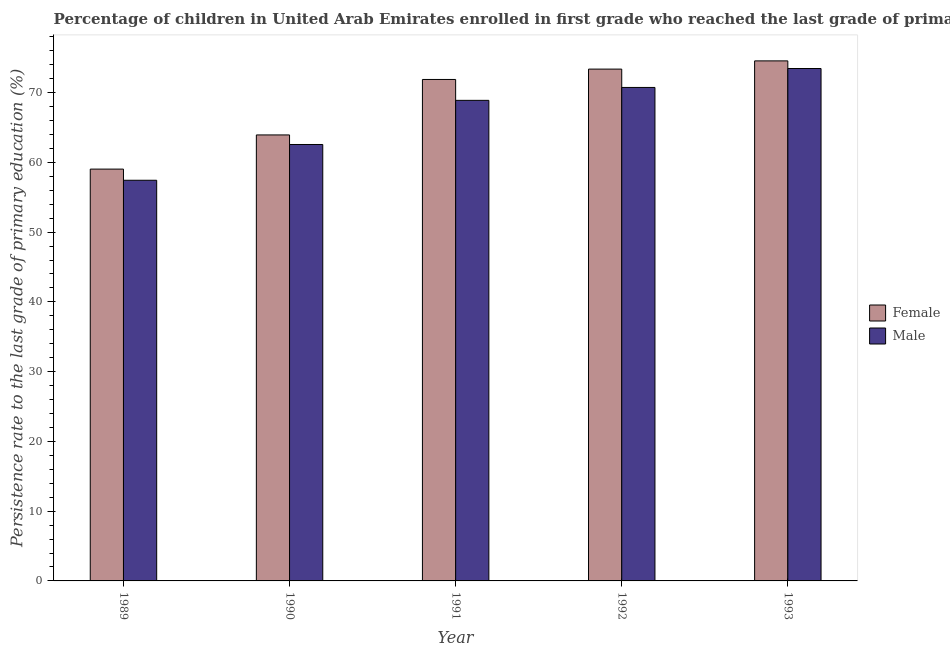How many different coloured bars are there?
Offer a terse response. 2. Are the number of bars on each tick of the X-axis equal?
Ensure brevity in your answer.  Yes. What is the persistence rate of female students in 1989?
Your response must be concise. 59.03. Across all years, what is the maximum persistence rate of male students?
Offer a terse response. 73.45. Across all years, what is the minimum persistence rate of male students?
Make the answer very short. 57.43. What is the total persistence rate of female students in the graph?
Ensure brevity in your answer.  342.75. What is the difference between the persistence rate of female students in 1989 and that in 1992?
Your answer should be compact. -14.33. What is the difference between the persistence rate of male students in 1990 and the persistence rate of female students in 1991?
Keep it short and to the point. -6.33. What is the average persistence rate of female students per year?
Your answer should be compact. 68.55. In how many years, is the persistence rate of male students greater than 72 %?
Offer a terse response. 1. What is the ratio of the persistence rate of male students in 1992 to that in 1993?
Offer a very short reply. 0.96. Is the persistence rate of male students in 1990 less than that in 1993?
Make the answer very short. Yes. What is the difference between the highest and the second highest persistence rate of female students?
Give a very brief answer. 1.18. What is the difference between the highest and the lowest persistence rate of female students?
Keep it short and to the point. 15.51. Is the sum of the persistence rate of female students in 1989 and 1993 greater than the maximum persistence rate of male students across all years?
Your answer should be very brief. Yes. What does the 2nd bar from the right in 1991 represents?
Your answer should be compact. Female. How many years are there in the graph?
Ensure brevity in your answer.  5. Are the values on the major ticks of Y-axis written in scientific E-notation?
Ensure brevity in your answer.  No. Does the graph contain grids?
Your answer should be compact. No. Where does the legend appear in the graph?
Offer a terse response. Center right. How many legend labels are there?
Offer a terse response. 2. What is the title of the graph?
Keep it short and to the point. Percentage of children in United Arab Emirates enrolled in first grade who reached the last grade of primary education. What is the label or title of the X-axis?
Provide a succinct answer. Year. What is the label or title of the Y-axis?
Give a very brief answer. Persistence rate to the last grade of primary education (%). What is the Persistence rate to the last grade of primary education (%) in Female in 1989?
Offer a terse response. 59.03. What is the Persistence rate to the last grade of primary education (%) of Male in 1989?
Ensure brevity in your answer.  57.43. What is the Persistence rate to the last grade of primary education (%) in Female in 1990?
Ensure brevity in your answer.  63.93. What is the Persistence rate to the last grade of primary education (%) of Male in 1990?
Keep it short and to the point. 62.56. What is the Persistence rate to the last grade of primary education (%) of Female in 1991?
Ensure brevity in your answer.  71.88. What is the Persistence rate to the last grade of primary education (%) of Male in 1991?
Provide a succinct answer. 68.89. What is the Persistence rate to the last grade of primary education (%) in Female in 1992?
Provide a short and direct response. 73.37. What is the Persistence rate to the last grade of primary education (%) of Male in 1992?
Keep it short and to the point. 70.74. What is the Persistence rate to the last grade of primary education (%) of Female in 1993?
Keep it short and to the point. 74.54. What is the Persistence rate to the last grade of primary education (%) of Male in 1993?
Your answer should be compact. 73.45. Across all years, what is the maximum Persistence rate to the last grade of primary education (%) in Female?
Provide a short and direct response. 74.54. Across all years, what is the maximum Persistence rate to the last grade of primary education (%) of Male?
Your response must be concise. 73.45. Across all years, what is the minimum Persistence rate to the last grade of primary education (%) in Female?
Offer a very short reply. 59.03. Across all years, what is the minimum Persistence rate to the last grade of primary education (%) in Male?
Your response must be concise. 57.43. What is the total Persistence rate to the last grade of primary education (%) of Female in the graph?
Offer a very short reply. 342.75. What is the total Persistence rate to the last grade of primary education (%) of Male in the graph?
Ensure brevity in your answer.  333.06. What is the difference between the Persistence rate to the last grade of primary education (%) in Female in 1989 and that in 1990?
Your response must be concise. -4.9. What is the difference between the Persistence rate to the last grade of primary education (%) of Male in 1989 and that in 1990?
Your response must be concise. -5.13. What is the difference between the Persistence rate to the last grade of primary education (%) of Female in 1989 and that in 1991?
Ensure brevity in your answer.  -12.85. What is the difference between the Persistence rate to the last grade of primary education (%) in Male in 1989 and that in 1991?
Provide a short and direct response. -11.45. What is the difference between the Persistence rate to the last grade of primary education (%) in Female in 1989 and that in 1992?
Your response must be concise. -14.33. What is the difference between the Persistence rate to the last grade of primary education (%) of Male in 1989 and that in 1992?
Offer a very short reply. -13.3. What is the difference between the Persistence rate to the last grade of primary education (%) of Female in 1989 and that in 1993?
Keep it short and to the point. -15.51. What is the difference between the Persistence rate to the last grade of primary education (%) of Male in 1989 and that in 1993?
Your response must be concise. -16.02. What is the difference between the Persistence rate to the last grade of primary education (%) in Female in 1990 and that in 1991?
Offer a terse response. -7.95. What is the difference between the Persistence rate to the last grade of primary education (%) in Male in 1990 and that in 1991?
Ensure brevity in your answer.  -6.33. What is the difference between the Persistence rate to the last grade of primary education (%) in Female in 1990 and that in 1992?
Ensure brevity in your answer.  -9.44. What is the difference between the Persistence rate to the last grade of primary education (%) in Male in 1990 and that in 1992?
Your response must be concise. -8.18. What is the difference between the Persistence rate to the last grade of primary education (%) of Female in 1990 and that in 1993?
Provide a short and direct response. -10.61. What is the difference between the Persistence rate to the last grade of primary education (%) in Male in 1990 and that in 1993?
Provide a short and direct response. -10.89. What is the difference between the Persistence rate to the last grade of primary education (%) of Female in 1991 and that in 1992?
Your response must be concise. -1.49. What is the difference between the Persistence rate to the last grade of primary education (%) of Male in 1991 and that in 1992?
Provide a short and direct response. -1.85. What is the difference between the Persistence rate to the last grade of primary education (%) of Female in 1991 and that in 1993?
Keep it short and to the point. -2.66. What is the difference between the Persistence rate to the last grade of primary education (%) of Male in 1991 and that in 1993?
Provide a short and direct response. -4.57. What is the difference between the Persistence rate to the last grade of primary education (%) of Female in 1992 and that in 1993?
Provide a short and direct response. -1.18. What is the difference between the Persistence rate to the last grade of primary education (%) in Male in 1992 and that in 1993?
Give a very brief answer. -2.71. What is the difference between the Persistence rate to the last grade of primary education (%) of Female in 1989 and the Persistence rate to the last grade of primary education (%) of Male in 1990?
Offer a very short reply. -3.53. What is the difference between the Persistence rate to the last grade of primary education (%) in Female in 1989 and the Persistence rate to the last grade of primary education (%) in Male in 1991?
Offer a terse response. -9.85. What is the difference between the Persistence rate to the last grade of primary education (%) of Female in 1989 and the Persistence rate to the last grade of primary education (%) of Male in 1992?
Offer a very short reply. -11.7. What is the difference between the Persistence rate to the last grade of primary education (%) of Female in 1989 and the Persistence rate to the last grade of primary education (%) of Male in 1993?
Offer a very short reply. -14.42. What is the difference between the Persistence rate to the last grade of primary education (%) of Female in 1990 and the Persistence rate to the last grade of primary education (%) of Male in 1991?
Give a very brief answer. -4.96. What is the difference between the Persistence rate to the last grade of primary education (%) of Female in 1990 and the Persistence rate to the last grade of primary education (%) of Male in 1992?
Keep it short and to the point. -6.81. What is the difference between the Persistence rate to the last grade of primary education (%) in Female in 1990 and the Persistence rate to the last grade of primary education (%) in Male in 1993?
Your answer should be compact. -9.52. What is the difference between the Persistence rate to the last grade of primary education (%) in Female in 1991 and the Persistence rate to the last grade of primary education (%) in Male in 1992?
Make the answer very short. 1.14. What is the difference between the Persistence rate to the last grade of primary education (%) of Female in 1991 and the Persistence rate to the last grade of primary education (%) of Male in 1993?
Offer a terse response. -1.57. What is the difference between the Persistence rate to the last grade of primary education (%) of Female in 1992 and the Persistence rate to the last grade of primary education (%) of Male in 1993?
Your answer should be very brief. -0.09. What is the average Persistence rate to the last grade of primary education (%) of Female per year?
Offer a very short reply. 68.55. What is the average Persistence rate to the last grade of primary education (%) of Male per year?
Make the answer very short. 66.61. In the year 1989, what is the difference between the Persistence rate to the last grade of primary education (%) in Female and Persistence rate to the last grade of primary education (%) in Male?
Provide a short and direct response. 1.6. In the year 1990, what is the difference between the Persistence rate to the last grade of primary education (%) in Female and Persistence rate to the last grade of primary education (%) in Male?
Give a very brief answer. 1.37. In the year 1991, what is the difference between the Persistence rate to the last grade of primary education (%) of Female and Persistence rate to the last grade of primary education (%) of Male?
Your answer should be very brief. 3. In the year 1992, what is the difference between the Persistence rate to the last grade of primary education (%) of Female and Persistence rate to the last grade of primary education (%) of Male?
Keep it short and to the point. 2.63. In the year 1993, what is the difference between the Persistence rate to the last grade of primary education (%) of Female and Persistence rate to the last grade of primary education (%) of Male?
Provide a short and direct response. 1.09. What is the ratio of the Persistence rate to the last grade of primary education (%) of Female in 1989 to that in 1990?
Provide a succinct answer. 0.92. What is the ratio of the Persistence rate to the last grade of primary education (%) of Male in 1989 to that in 1990?
Ensure brevity in your answer.  0.92. What is the ratio of the Persistence rate to the last grade of primary education (%) in Female in 1989 to that in 1991?
Ensure brevity in your answer.  0.82. What is the ratio of the Persistence rate to the last grade of primary education (%) of Male in 1989 to that in 1991?
Your answer should be very brief. 0.83. What is the ratio of the Persistence rate to the last grade of primary education (%) in Female in 1989 to that in 1992?
Offer a very short reply. 0.8. What is the ratio of the Persistence rate to the last grade of primary education (%) of Male in 1989 to that in 1992?
Provide a succinct answer. 0.81. What is the ratio of the Persistence rate to the last grade of primary education (%) of Female in 1989 to that in 1993?
Your answer should be very brief. 0.79. What is the ratio of the Persistence rate to the last grade of primary education (%) in Male in 1989 to that in 1993?
Your response must be concise. 0.78. What is the ratio of the Persistence rate to the last grade of primary education (%) in Female in 1990 to that in 1991?
Provide a succinct answer. 0.89. What is the ratio of the Persistence rate to the last grade of primary education (%) of Male in 1990 to that in 1991?
Your response must be concise. 0.91. What is the ratio of the Persistence rate to the last grade of primary education (%) in Female in 1990 to that in 1992?
Make the answer very short. 0.87. What is the ratio of the Persistence rate to the last grade of primary education (%) in Male in 1990 to that in 1992?
Your answer should be very brief. 0.88. What is the ratio of the Persistence rate to the last grade of primary education (%) in Female in 1990 to that in 1993?
Provide a succinct answer. 0.86. What is the ratio of the Persistence rate to the last grade of primary education (%) of Male in 1990 to that in 1993?
Make the answer very short. 0.85. What is the ratio of the Persistence rate to the last grade of primary education (%) in Female in 1991 to that in 1992?
Make the answer very short. 0.98. What is the ratio of the Persistence rate to the last grade of primary education (%) of Male in 1991 to that in 1992?
Ensure brevity in your answer.  0.97. What is the ratio of the Persistence rate to the last grade of primary education (%) in Male in 1991 to that in 1993?
Offer a very short reply. 0.94. What is the ratio of the Persistence rate to the last grade of primary education (%) in Female in 1992 to that in 1993?
Give a very brief answer. 0.98. What is the difference between the highest and the second highest Persistence rate to the last grade of primary education (%) in Female?
Keep it short and to the point. 1.18. What is the difference between the highest and the second highest Persistence rate to the last grade of primary education (%) of Male?
Your answer should be compact. 2.71. What is the difference between the highest and the lowest Persistence rate to the last grade of primary education (%) of Female?
Your answer should be compact. 15.51. What is the difference between the highest and the lowest Persistence rate to the last grade of primary education (%) in Male?
Provide a short and direct response. 16.02. 